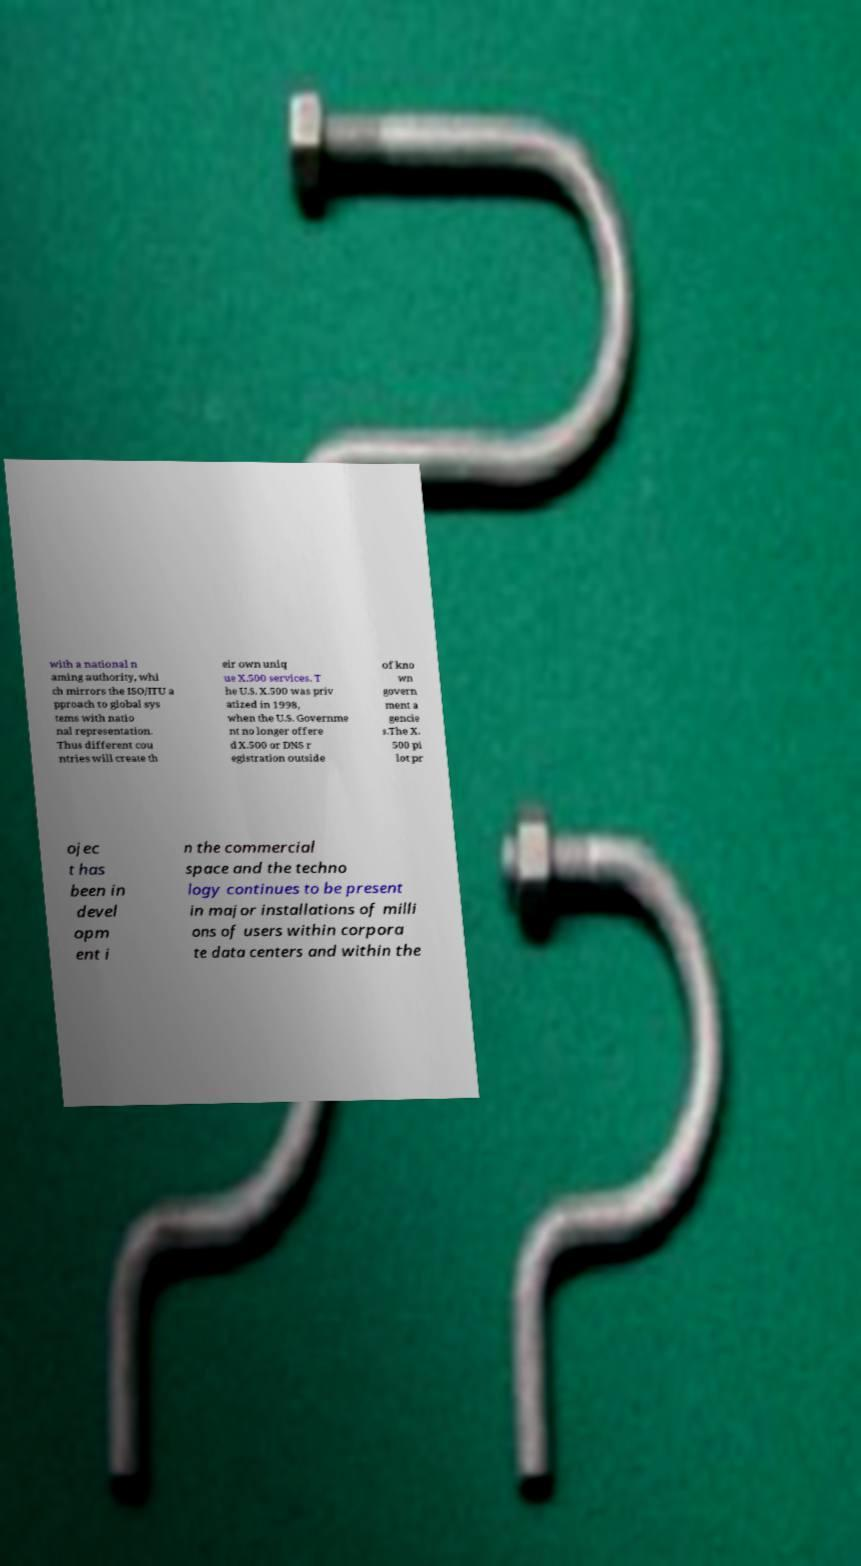Can you read and provide the text displayed in the image?This photo seems to have some interesting text. Can you extract and type it out for me? with a national n aming authority, whi ch mirrors the ISO/ITU a pproach to global sys tems with natio nal representation. Thus different cou ntries will create th eir own uniq ue X.500 services. T he U.S. X.500 was priv atized in 1998, when the U.S. Governme nt no longer offere d X.500 or DNS r egistration outside of kno wn govern ment a gencie s.The X. 500 pi lot pr ojec t has been in devel opm ent i n the commercial space and the techno logy continues to be present in major installations of milli ons of users within corpora te data centers and within the 